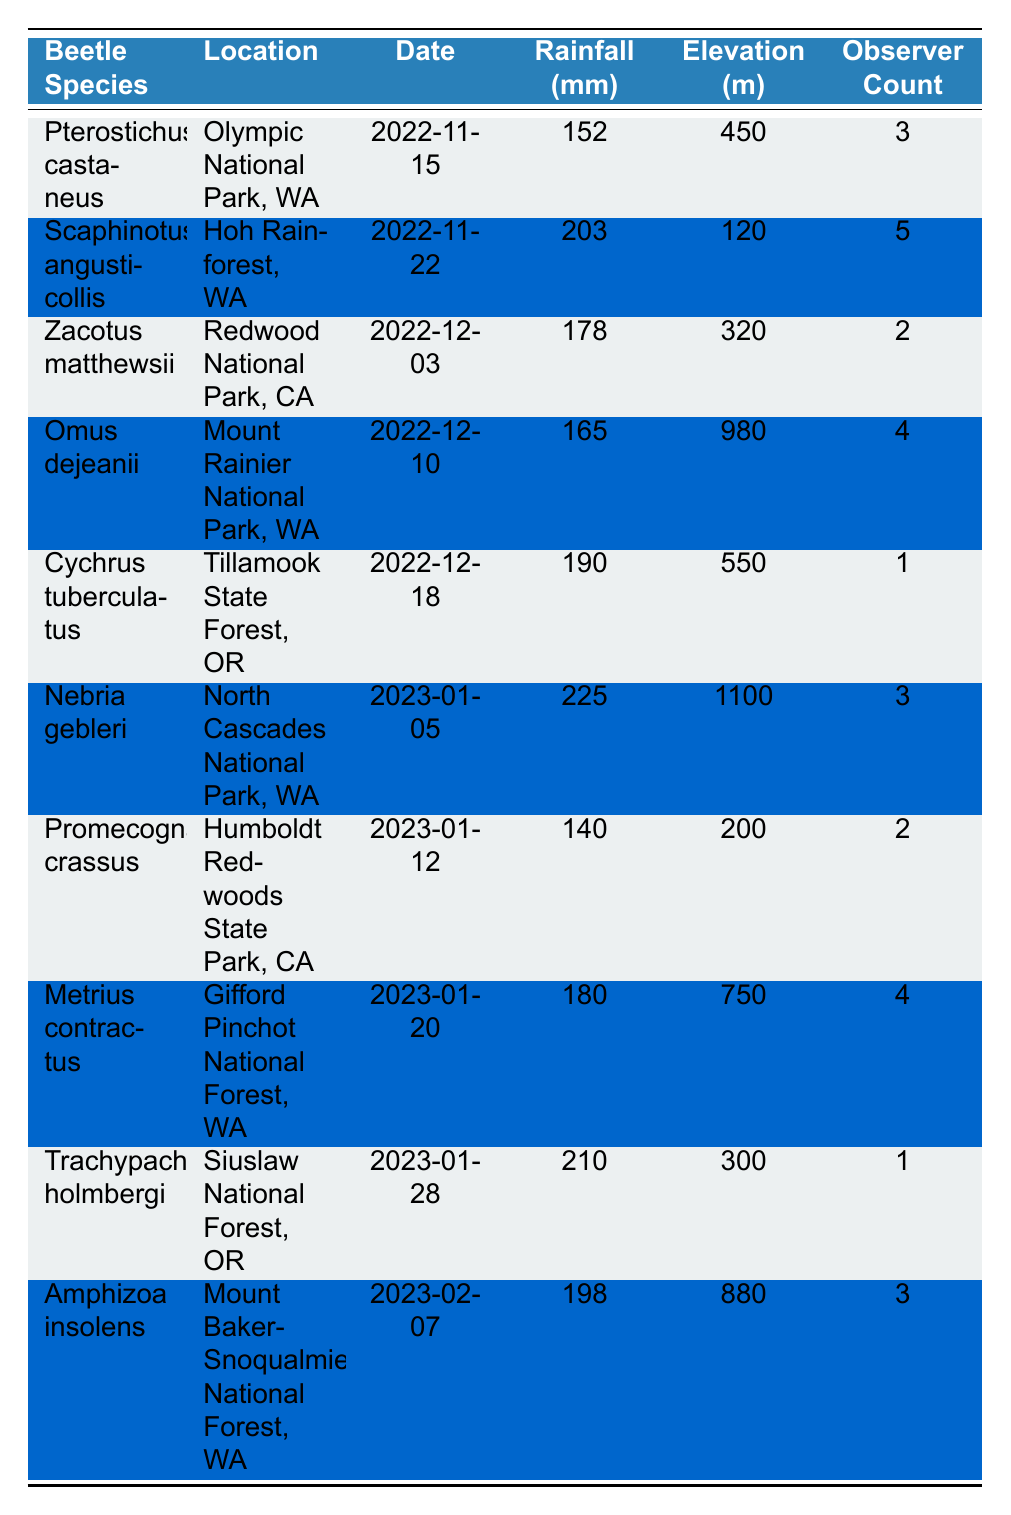What is the most frequently observed beetle species in the table? By reviewing the 'Observer Count' column, the highest number of observers recorded is 5 for "Scaphinotus angusticollis." Therefore, it is the most frequently observed species.
Answer: Scaphinotus angusticollis What was the rainfall amount on the date when "Pterostichus castaneus" was observed? Looking at the row for "Pterostichus castaneus," the rainfall recorded on 2022-11-15 is 152 mm.
Answer: 152 mm Which beetle species was observed at the highest elevation and what was that elevation? The row for "Nebria gebleri" shows that it was observed at 1100 m, which is the highest elevation recorded in the table.
Answer: Nebria gebleri, 1100 m What is the average rainfall recorded across all sightings? By adding the rainfall amounts (152 + 203 + 178 + 165 + 190 + 225 + 140 + 180 + 210 + 198) = 1891 mm and dividing by the number of sightings (10), the average rainfall is 189.1 mm.
Answer: 189.1 mm Was there any beetle species observed with only 1 observer? The table indicates that "Cychrus tuberculatus" and "Trachypachus holmbergi" both had 1 observer, confirming that at least one species was recorded with only one observer.
Answer: Yes Which beetle species recorded the least amount of rainfall and how much was it? Scanning the rainfall figures, "Promecognathus crassus" had the least rainfall at 140 mm, making it the species with the lowest rainfall record.
Answer: Promecognathus crassus, 140 mm How many beetle species were observed in Olympic National Park? The table lists only "Pterostichus castaneus" as the beetle species observed in Olympic National Park, thus the total is 1.
Answer: 1 What was the total observer count for all beetle sightings recorded in North Cascades National Park? For "Nebria gebleri" in North Cascades National Park, the observer count is 3. There are no other sightings from this park, so the total observer count is 3.
Answer: 3 How does the amount of rainfall on the date of "Omus dejeanii" compare with the average rainfall? "Omus dejeanii" recorded 165 mm of rainfall. The average rainfall calculated previously is 189.1 mm; since 165 is less than 189.1, it can be concluded that it is below average.
Answer: Below average What species had the highest rainfall and what was its amount? "Nebria gebleri" recorded the highest rainfall amount of 225 mm on the date specified, which is the largest in the rainfall column.
Answer: Nebria gebleri, 225 mm 